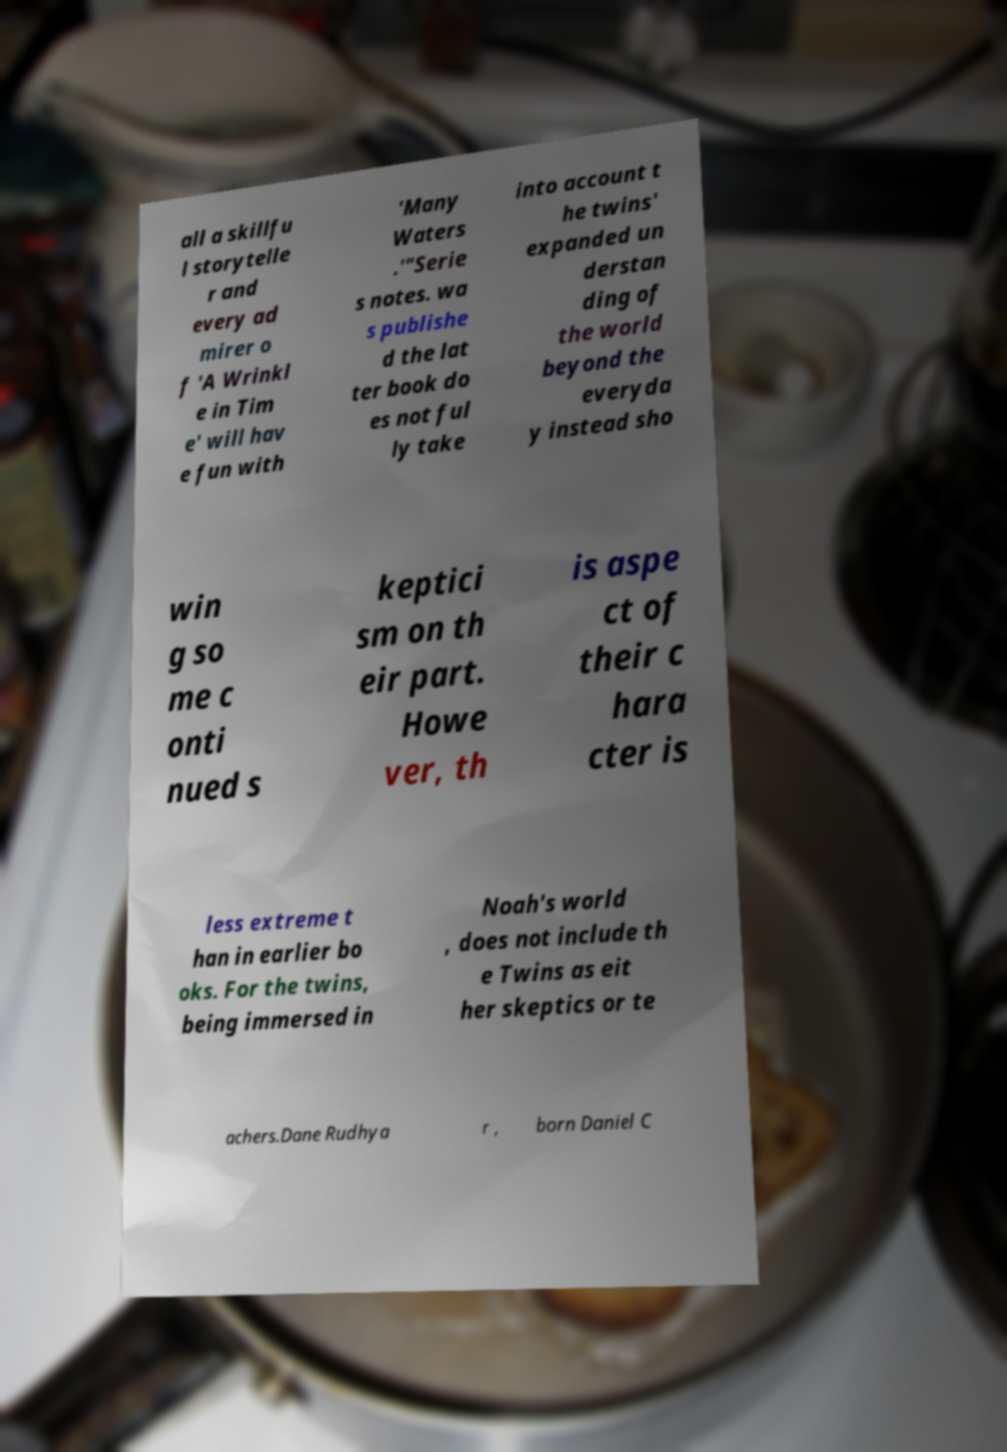What messages or text are displayed in this image? I need them in a readable, typed format. all a skillfu l storytelle r and every ad mirer o f 'A Wrinkl e in Tim e' will hav e fun with 'Many Waters .'"Serie s notes. wa s publishe d the lat ter book do es not ful ly take into account t he twins' expanded un derstan ding of the world beyond the everyda y instead sho win g so me c onti nued s keptici sm on th eir part. Howe ver, th is aspe ct of their c hara cter is less extreme t han in earlier bo oks. For the twins, being immersed in Noah's world , does not include th e Twins as eit her skeptics or te achers.Dane Rudhya r , born Daniel C 